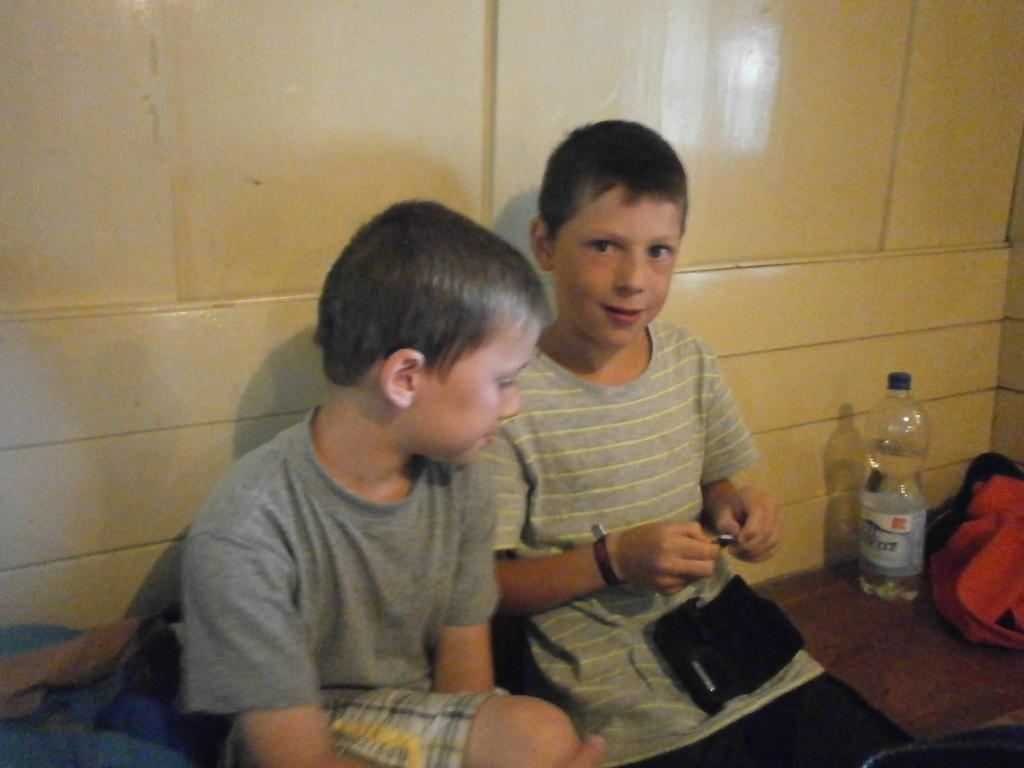How many people are in the image? There are two persons in the image. What objects can be seen besides the people? There is a bottle and a bag in the image. What can be seen in the background of the image? There is a wall in the background of the image. Can you see a flock of birds flying in the image? There is no flock of birds visible in the image. 